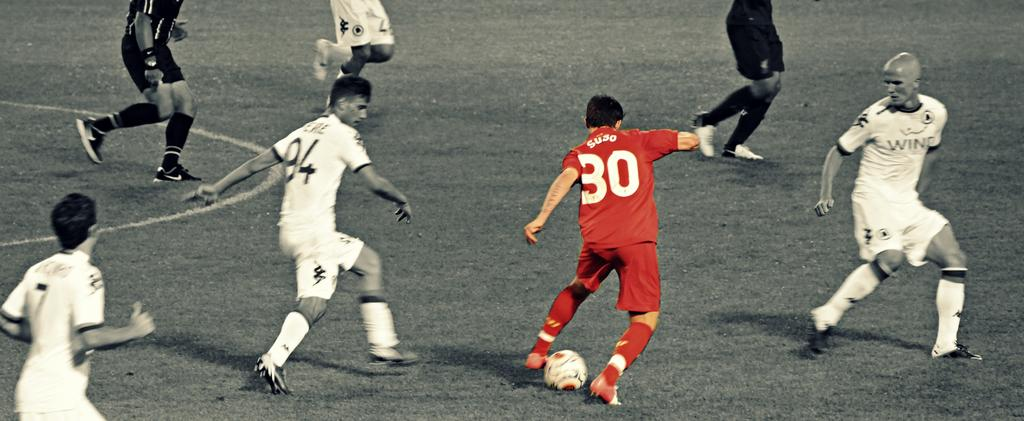<image>
Share a concise interpretation of the image provided. The soccer player is wearing the number 30. 